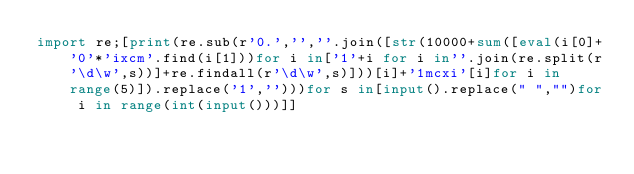Convert code to text. <code><loc_0><loc_0><loc_500><loc_500><_Python_>import re;[print(re.sub(r'0.','',''.join([str(10000+sum([eval(i[0]+'0'*'ixcm'.find(i[1]))for i in['1'+i for i in''.join(re.split(r'\d\w',s))]+re.findall(r'\d\w',s)]))[i]+'1mcxi'[i]for i in range(5)]).replace('1','')))for s in[input().replace(" ","")for i in range(int(input()))]]</code> 